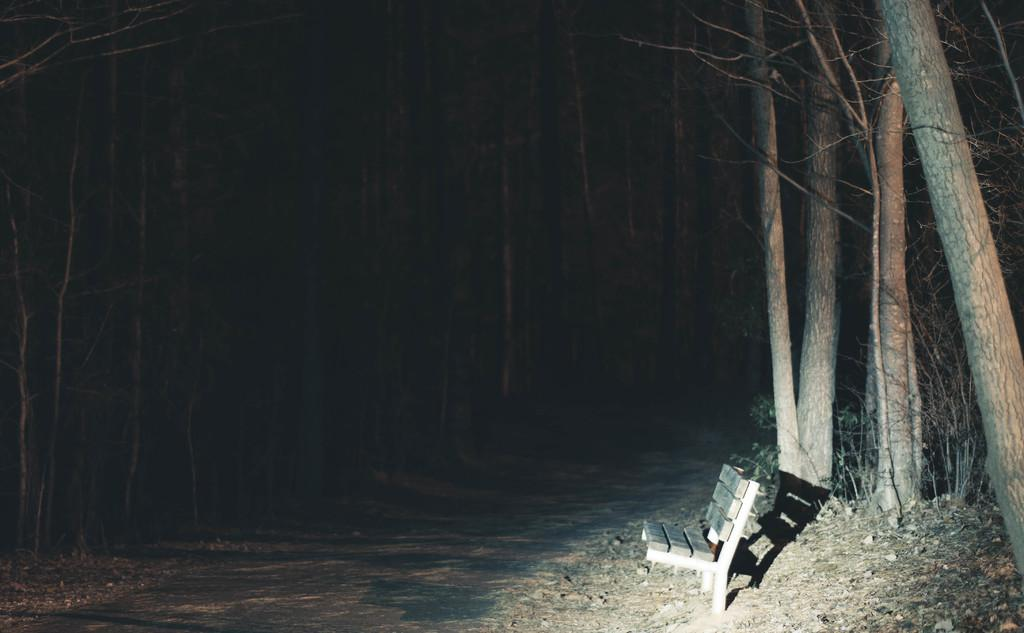What is located at the bottom of the image? There is a road at the bottom of the image. What can be seen on the right side of the image? There is a bench on the right side of the image. What type of vegetation is in the middle of the image? There are trees in the middle of the image. What time of day is depicted in the image? The image is set during nighttime. What rhythm is the music playing in the image? There is no music or rhythm present in the image; it features a road, a bench, trees, and is set during nighttime. 